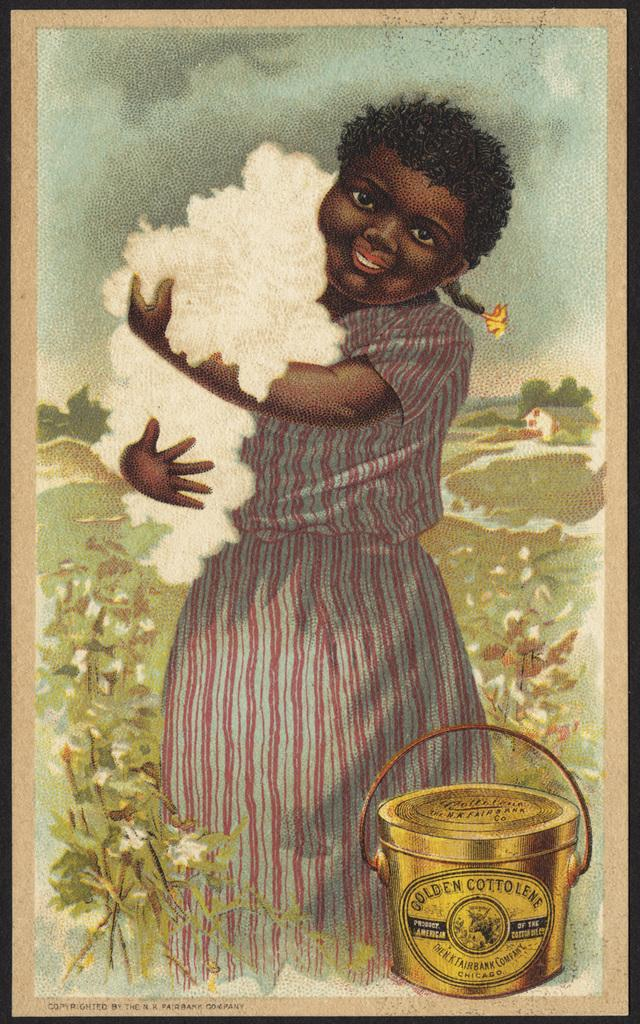<image>
Share a concise interpretation of the image provided. An old advertisement for Golden Cottolene features a young girl holding cotton. 